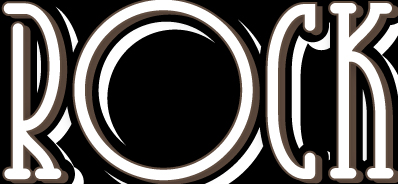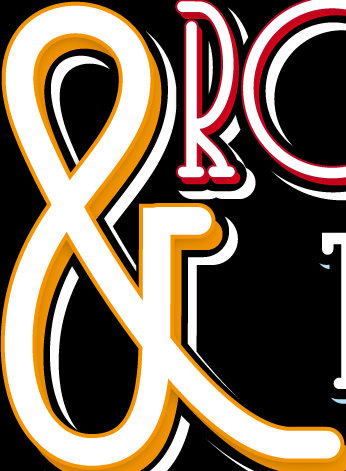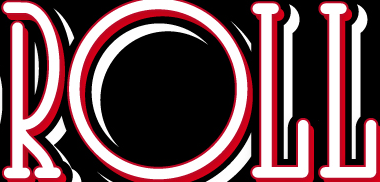Identify the words shown in these images in order, separated by a semicolon. ROCK; &; ROLL 